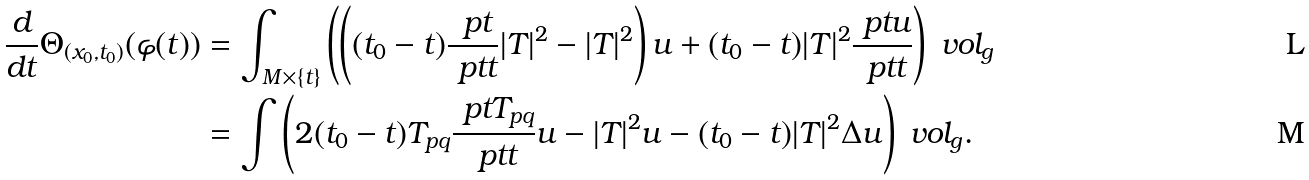Convert formula to latex. <formula><loc_0><loc_0><loc_500><loc_500>\frac { d } { d t } \Theta _ { ( x _ { 0 } , t _ { 0 } ) } ( \varphi ( t ) ) & = \int _ { M \times \{ t \} } \left ( \left ( ( t _ { 0 } - t ) \frac { \ p t } { \ p t t } | T | ^ { 2 } - | T | ^ { 2 } \right ) u + ( t _ { 0 } - t ) | T | ^ { 2 } \frac { \ p t u } { \ p t t } \right ) \ v o l _ { g } \\ & = \int \left ( 2 ( t _ { 0 } - t ) T _ { p q } \frac { \ p t T _ { p q } } { \ p t t } u - | T | ^ { 2 } u - ( t _ { 0 } - t ) | T | ^ { 2 } \Delta u \right ) \ v o l _ { g } .</formula> 